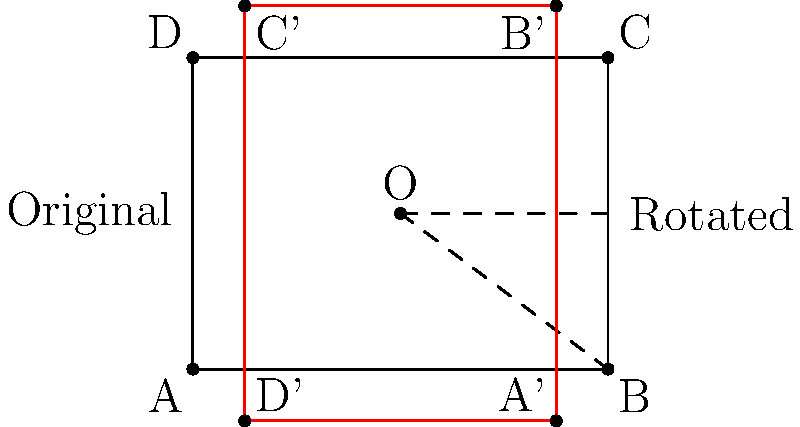A circuit board design is represented by the rectangular shape ABCD. If the design is rotated 90° counterclockwise around point O (2, 1.5), what will be the coordinates of point B after rotation? To solve this problem, we'll follow these steps:

1) Identify the original coordinates of point B: (4, 0)

2) Identify the center of rotation O: (2, 1.5)

3) Use the rotation formula:
   For a 90° counterclockwise rotation around point (a, b), the formula is:
   $$(x', y') = (-(y-b) + a, (x-a) + b)$$
   Where (x, y) are the original coordinates and (x', y') are the new coordinates.

4) Plug in the values:
   x = 4, y = 0 (coordinates of B)
   a = 2, b = 1.5 (coordinates of O)

5) Calculate:
   $x' = -(0 - 1.5) + 2 = 1.5 + 2 = 3.5$
   $y' = (4 - 2) + 1.5 = 2 + 1.5 = 3.5$

Therefore, after rotation, point B will be at coordinates (3.5, 3.5).
Answer: (3.5, 3.5) 